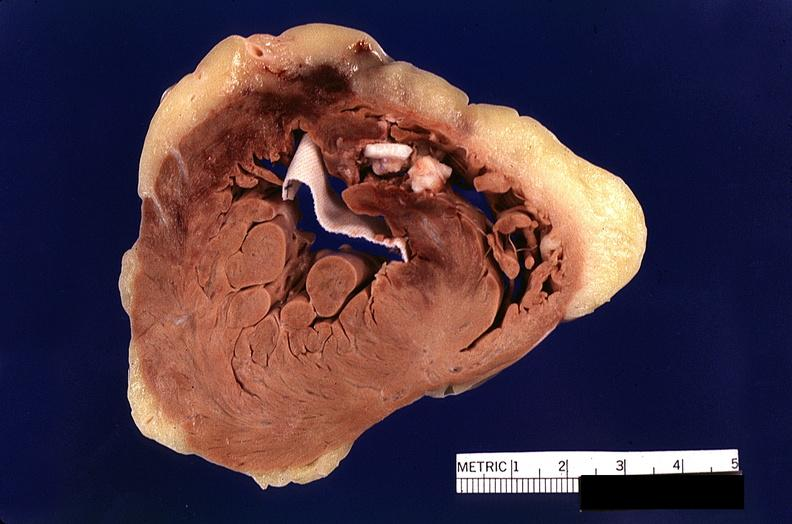does this image show heart, myocardial infarction, surgery to repair interventricular septum rupture?
Answer the question using a single word or phrase. Yes 